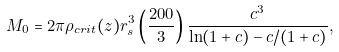Convert formula to latex. <formula><loc_0><loc_0><loc_500><loc_500>M _ { 0 } = 2 \pi \rho _ { c r i t } ( z ) r _ { s } ^ { 3 } \left ( \frac { 2 0 0 } { 3 } \right ) \frac { c ^ { 3 } } { \ln ( 1 + c ) - c / ( 1 + c ) } ,</formula> 